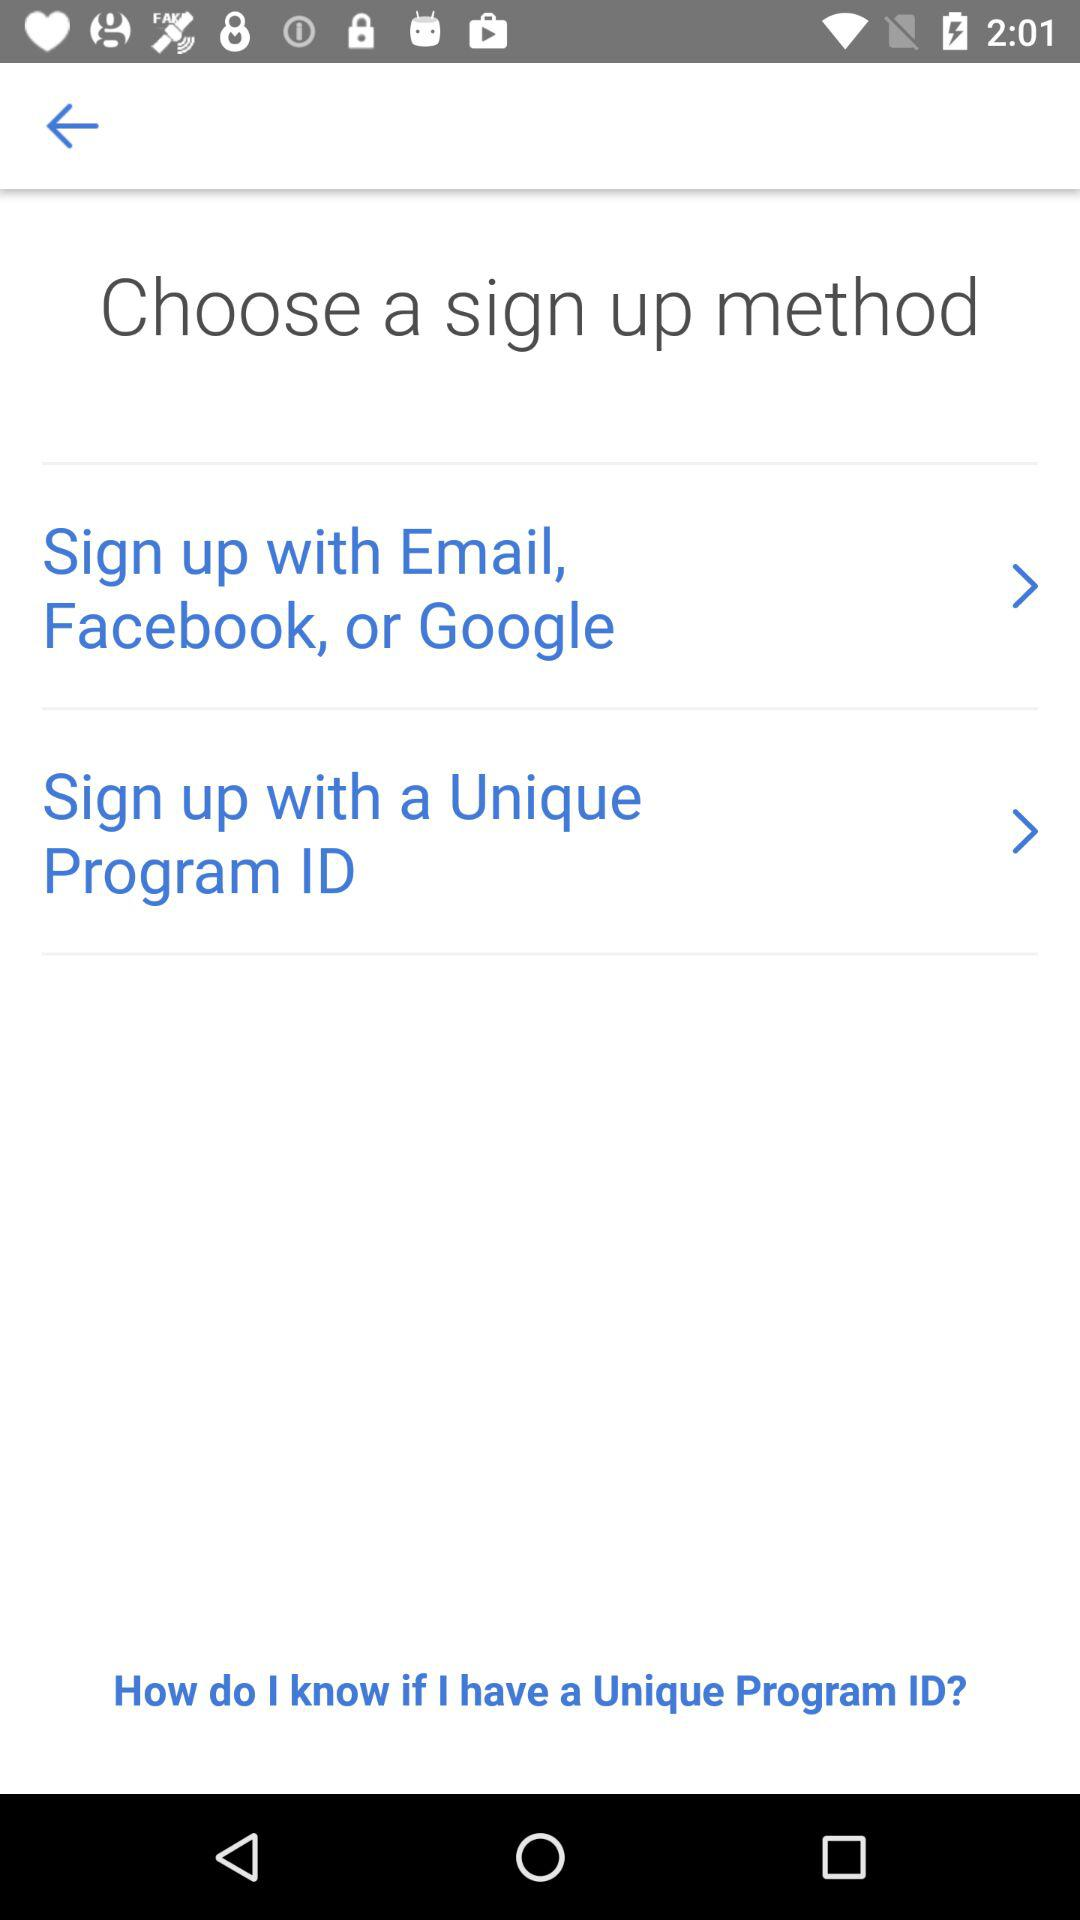How many sign up methods have a forward arrow?
Answer the question using a single word or phrase. 2 